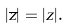<formula> <loc_0><loc_0><loc_500><loc_500>| { \overline { z } } | = | z | .</formula> 